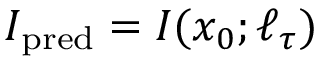Convert formula to latex. <formula><loc_0><loc_0><loc_500><loc_500>I _ { p r e d } = I ( x _ { 0 } ; \ell _ { \tau } )</formula> 